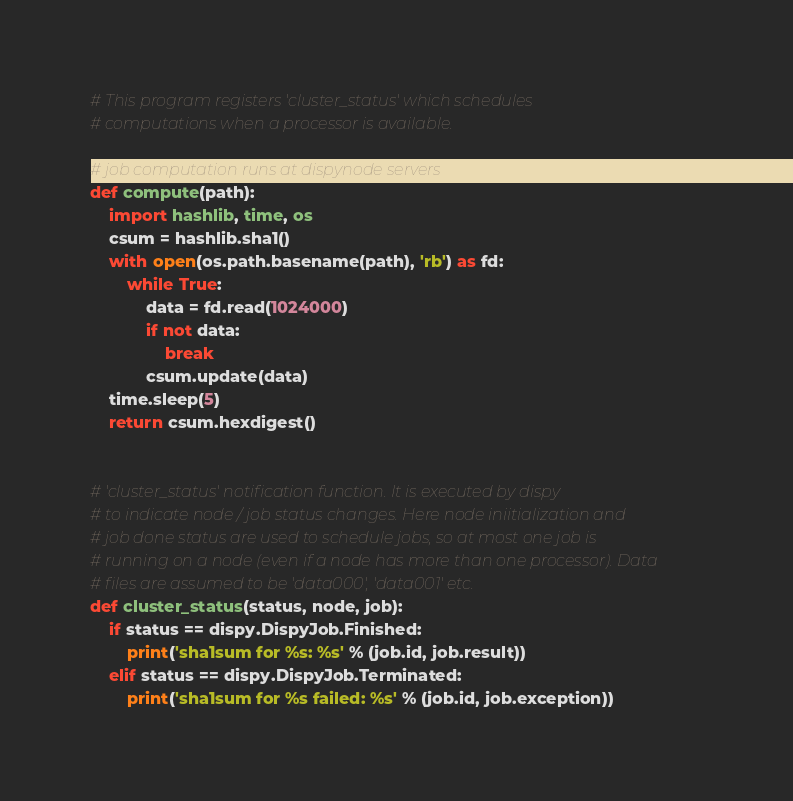<code> <loc_0><loc_0><loc_500><loc_500><_Python_># This program registers 'cluster_status' which schedules
# computations when a processor is available.

# job computation runs at dispynode servers
def compute(path):
    import hashlib, time, os
    csum = hashlib.sha1()
    with open(os.path.basename(path), 'rb') as fd:
        while True:
            data = fd.read(1024000)
            if not data:
                break
            csum.update(data)
    time.sleep(5)
    return csum.hexdigest()


# 'cluster_status' notification function. It is executed by dispy
# to indicate node / job status changes. Here node iniitialization and
# job done status are used to schedule jobs, so at most one job is
# running on a node (even if a node has more than one processor). Data
# files are assumed to be 'data000', 'data001' etc.
def cluster_status(status, node, job):
    if status == dispy.DispyJob.Finished:
        print('sha1sum for %s: %s' % (job.id, job.result))
    elif status == dispy.DispyJob.Terminated:
        print('sha1sum for %s failed: %s' % (job.id, job.exception))</code> 